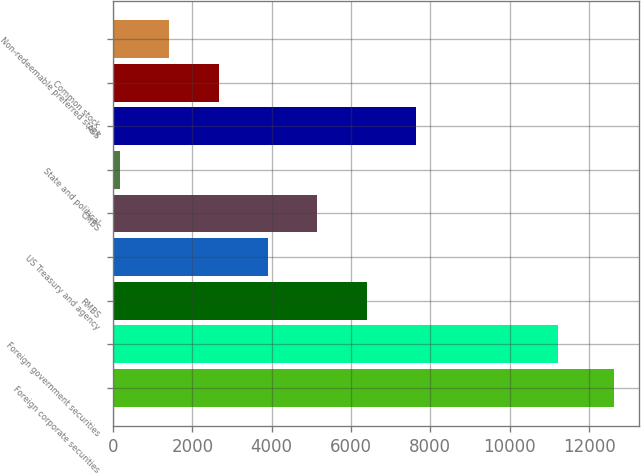Convert chart to OTSL. <chart><loc_0><loc_0><loc_500><loc_500><bar_chart><fcel>Foreign corporate securities<fcel>Foreign government securities<fcel>RMBS<fcel>US Treasury and agency<fcel>CMBS<fcel>State and political<fcel>ABS<fcel>Common stock<fcel>Non-redeemable preferred stock<nl><fcel>12618<fcel>11227<fcel>6397.5<fcel>3909.3<fcel>5153.4<fcel>177<fcel>7641.6<fcel>2665.2<fcel>1421.1<nl></chart> 